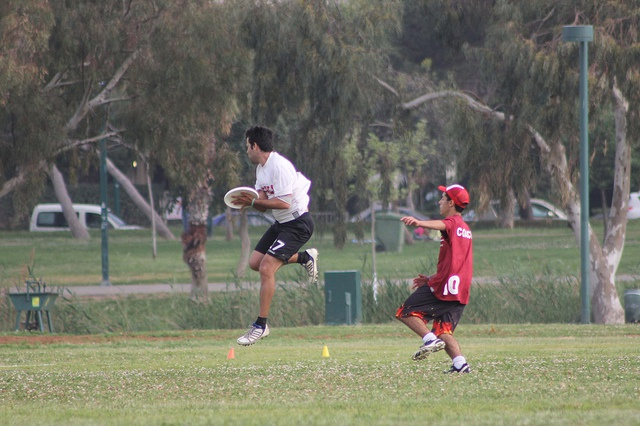Describe the objects in this image and their specific colors. I can see people in gray, lavender, and black tones, people in gray, black, salmon, and maroon tones, car in gray, darkgray, black, and purple tones, car in gray tones, and car in gray and darkgray tones in this image. 